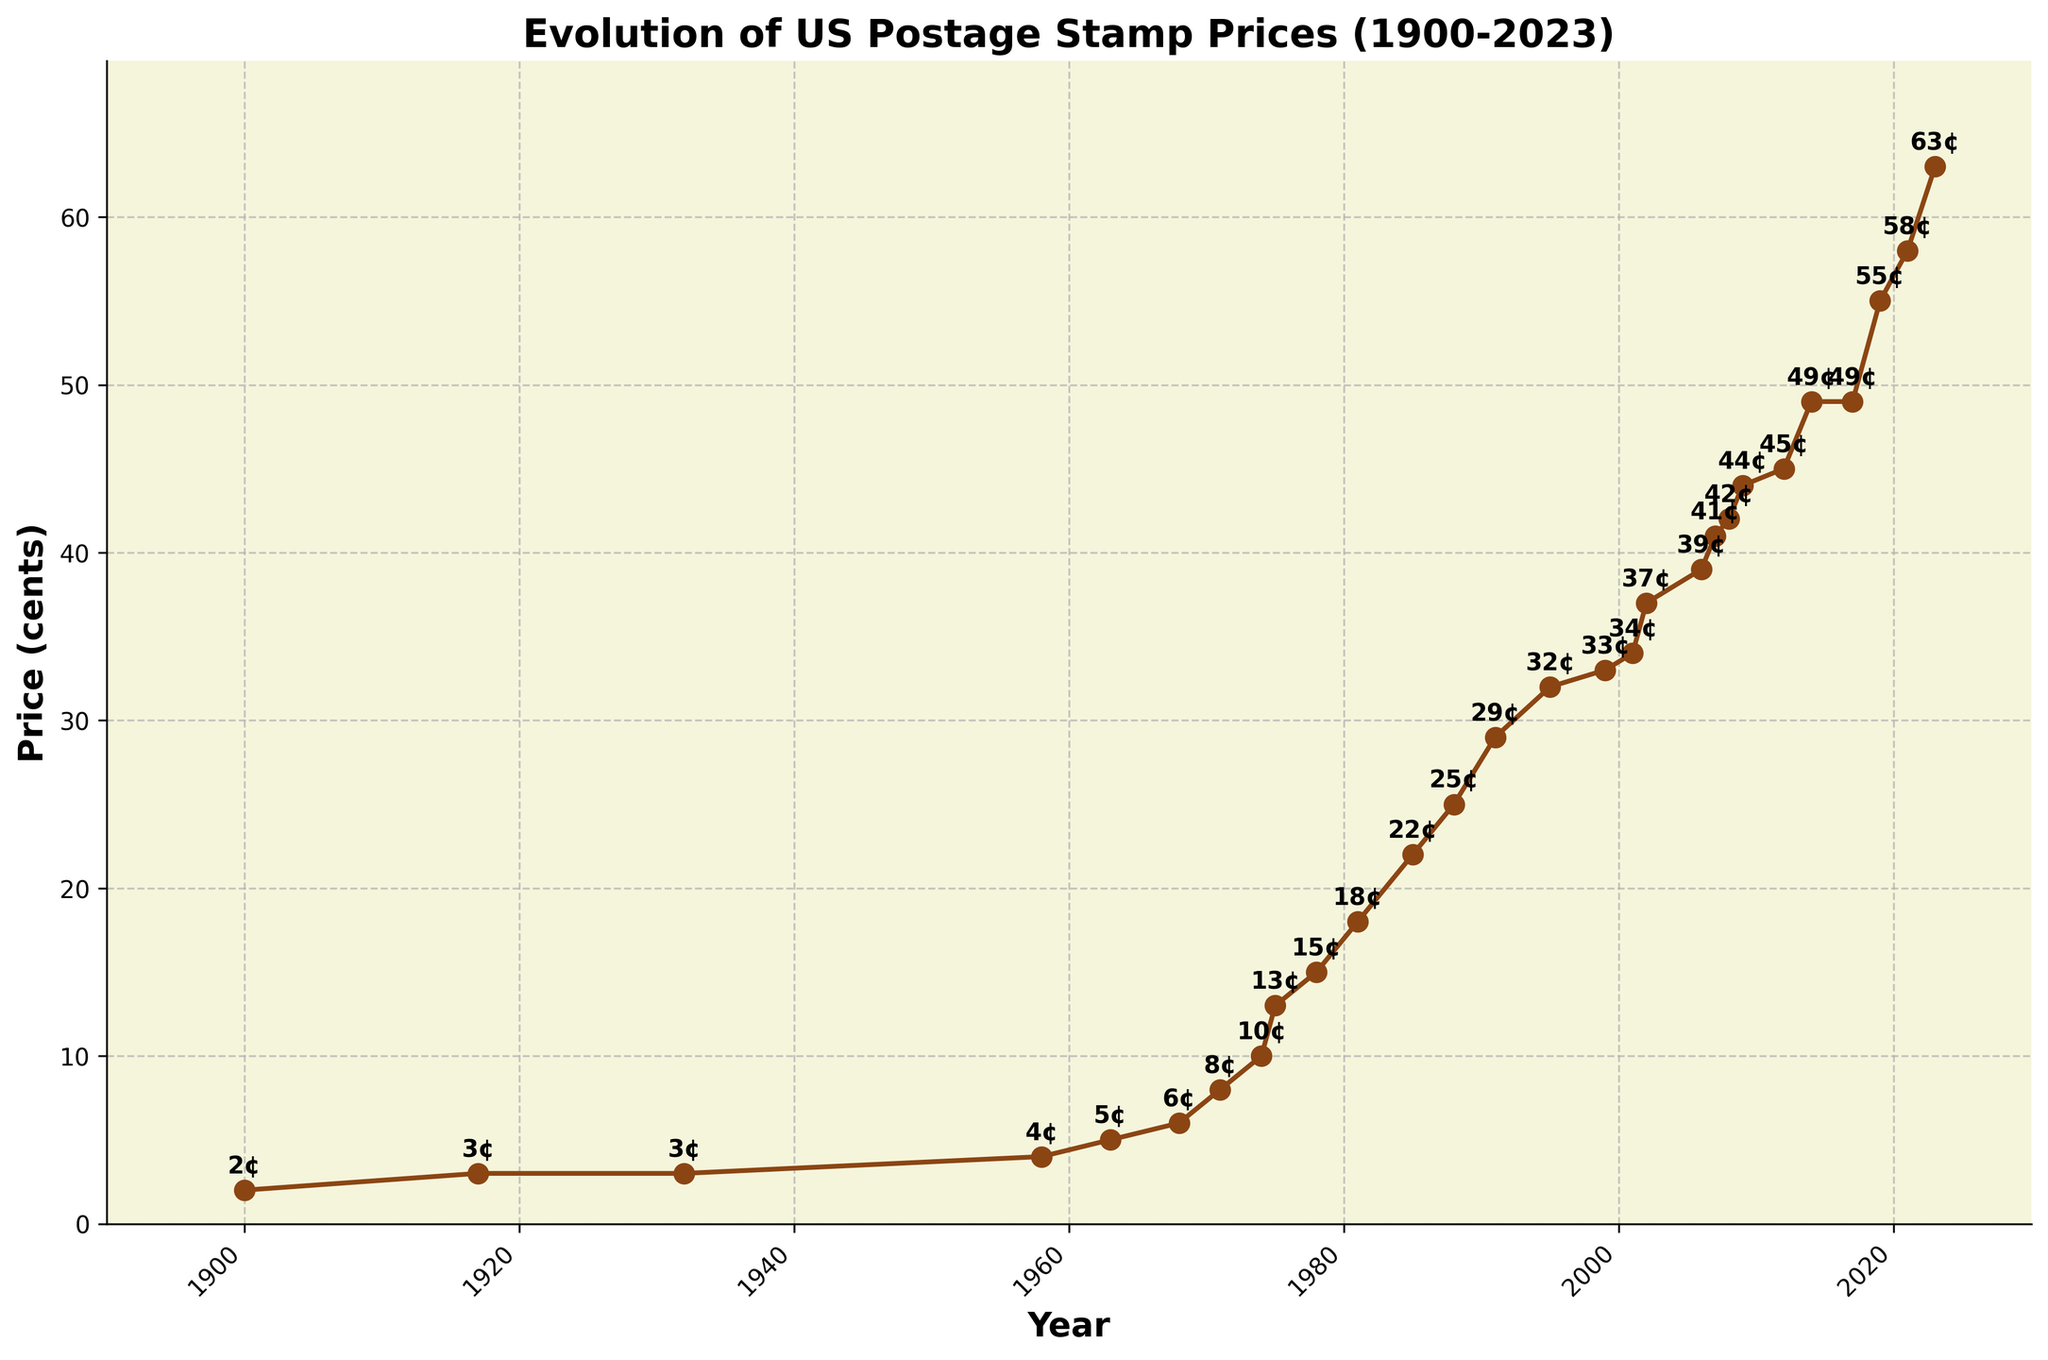What year did the postage stamp price first exceed 10 cents? The postage stamp price exceeded 10 cents for the first time in 1974 when it reached 13 cents.
Answer: 1974 What is the price difference between the stamps in 2001 and 2023? The stamp price in 2001 was 34 cents, and it increased to 63 cents in 2023. The price difference is 63 - 34 = 29 cents.
Answer: 29 cents How many years did it take for the stamp price to double from 18 to 37 cents? The stamp price was 18 cents in 1981 and reached 37 cents in 2002. The time difference is 2002 - 1981 = 21 years.
Answer: 21 years Which decade saw the highest increase in postage stamp price, and what was the increase? The decade from 1970 to 1980 saw the highest increase. In 1971, the price was 8 cents, and in 1980, it was 15 cents. The increase was 15 - 8 = 7 cents.
Answer: 1970s, 7 cents During which two consecutive years was there the largest price increase, and what was the increase? The largest price increase between two consecutive years was between 2017 and 2019. The price increased from 49 cents to 55 cents, which is an increase of 55 - 49 = 6 cents.
Answer: 2017-2019, 6 cents 